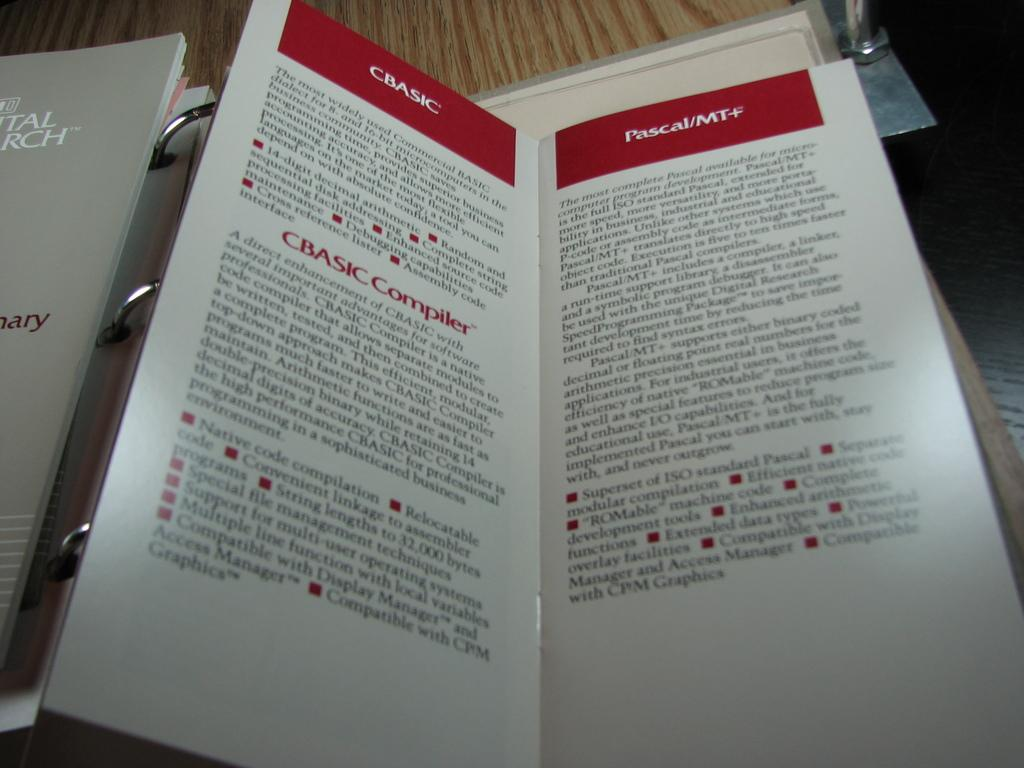<image>
Describe the image concisely. A pamphlet gives information about CBasic and the CBasic Compiler. 